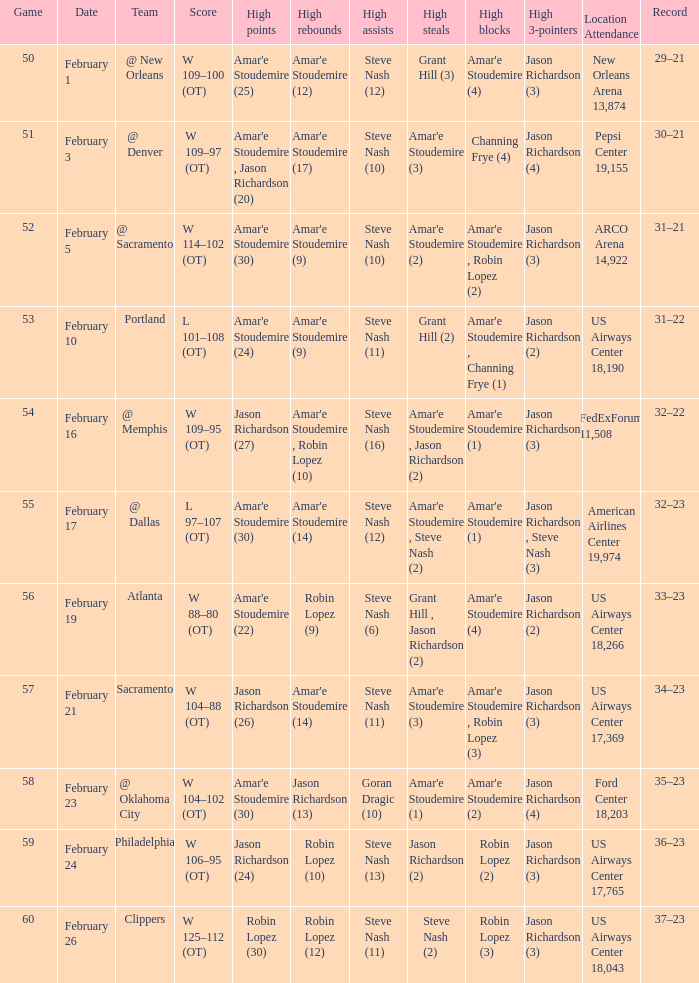Name the date for score w 109–95 (ot) February 16. 